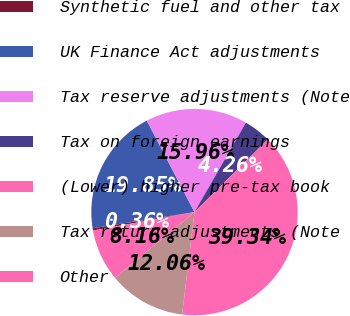<chart> <loc_0><loc_0><loc_500><loc_500><pie_chart><fcel>Synthetic fuel and other tax<fcel>UK Finance Act adjustments<fcel>Tax reserve adjustments (Note<fcel>Tax on foreign earnings<fcel>(Lower) higher pre-tax book<fcel>Tax return adjustments (Note<fcel>Other<nl><fcel>0.36%<fcel>19.85%<fcel>15.96%<fcel>4.26%<fcel>39.34%<fcel>12.06%<fcel>8.16%<nl></chart> 